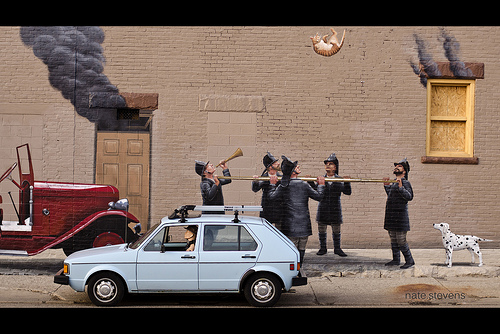<image>
Is there a white car on the red truck? No. The white car is not positioned on the red truck. They may be near each other, but the white car is not supported by or resting on top of the red truck. Is the dog to the right of the cat? No. The dog is not to the right of the cat. The horizontal positioning shows a different relationship. Is there a dog in front of the fireman? No. The dog is not in front of the fireman. The spatial positioning shows a different relationship between these objects. 